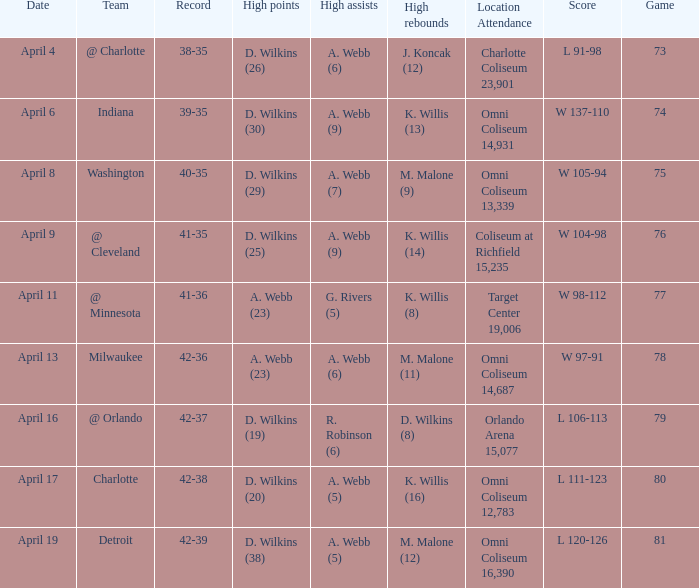What was the date of the game when g. rivers (5) had the  high assists? April 11. 